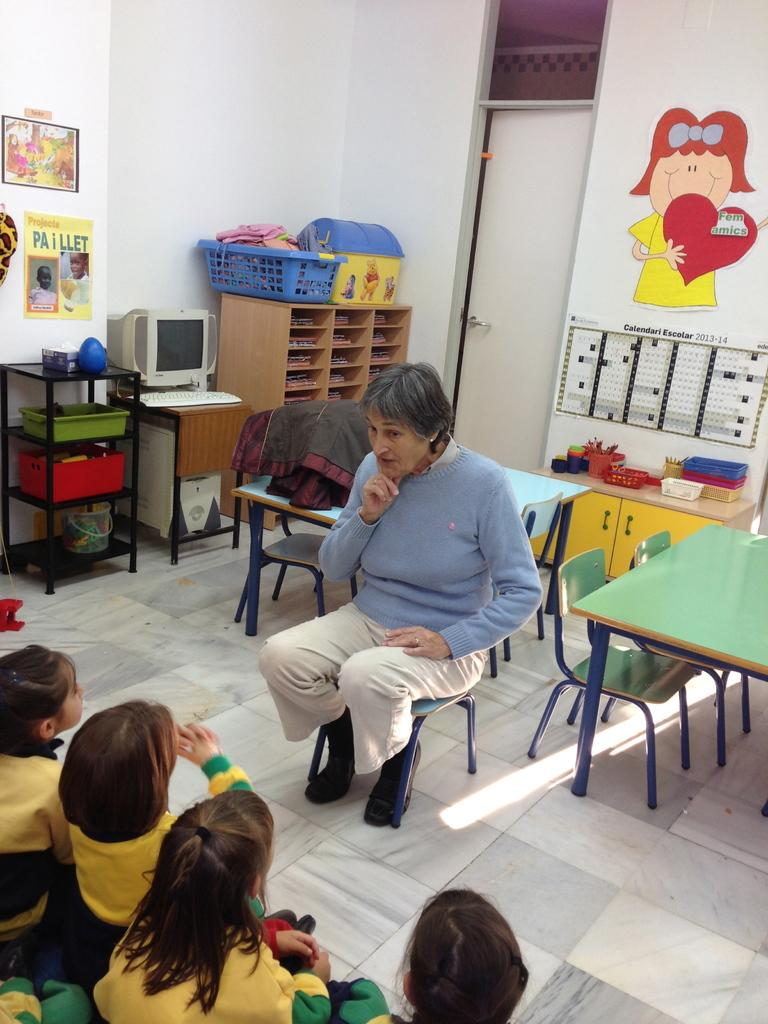Provide a one-sentence caption for the provided image. A yellow poster is hung on a wall titled, "Paillet.". 